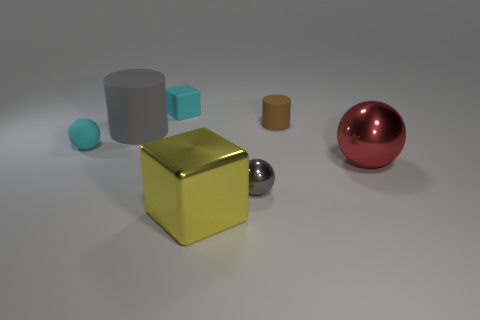There is a small cyan thing that is right of the rubber sphere; is its shape the same as the big gray rubber object?
Ensure brevity in your answer.  No. There is a tiny object that is the same material as the large yellow object; what color is it?
Give a very brief answer. Gray. There is a cylinder that is to the left of the brown thing; what is its material?
Keep it short and to the point. Rubber. Does the big red metal thing have the same shape as the tiny cyan thing that is on the left side of the large cylinder?
Offer a terse response. Yes. There is a small object that is left of the yellow block and behind the small cyan ball; what is it made of?
Ensure brevity in your answer.  Rubber. There is another ball that is the same size as the cyan rubber ball; what is its color?
Make the answer very short. Gray. Are the big cylinder and the gray thing that is right of the big block made of the same material?
Give a very brief answer. No. What number of other things are the same size as the matte block?
Give a very brief answer. 3. Is there a cylinder that is right of the rubber thing right of the block that is behind the cyan matte ball?
Your answer should be compact. No. How big is the brown rubber cylinder?
Keep it short and to the point. Small. 